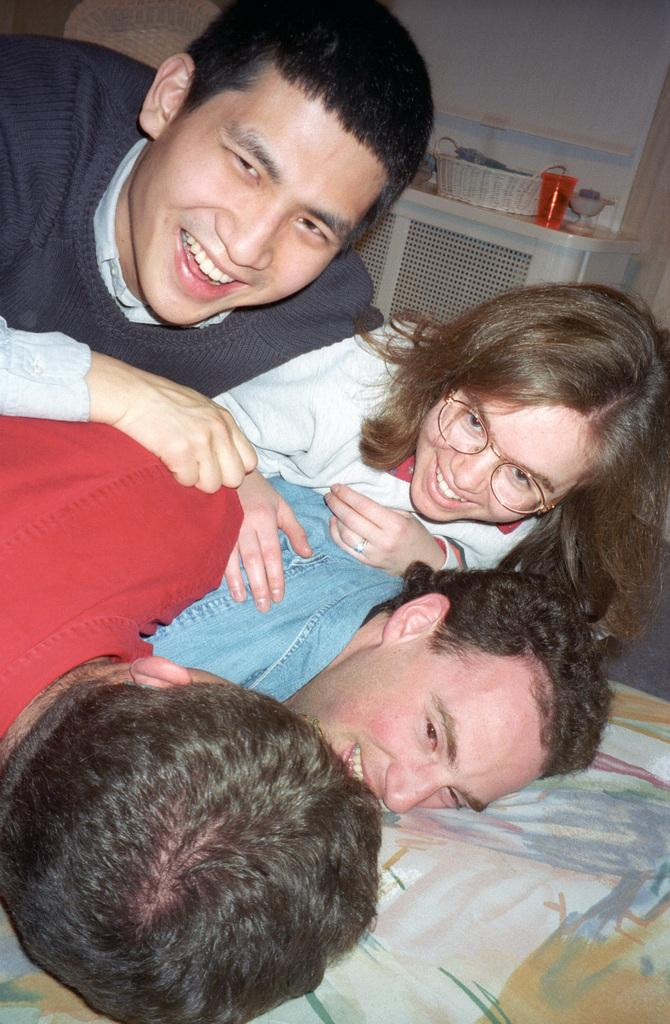How many people are in the image? There are four persons in the image. What is the facial expression of the people in the image? The persons are smiling. What object can be seen in the image besides the people? There is a basket and a glass on a platform in the image. What is visible in the background of the image? There is a wall in the background of the image. What type of string can be seen tied to the glass in the image? There is no string tied to the glass in the image. Can you see any goldfish swimming in the basket in the image? There are no goldfish present in the image; it only features a basket and a glass on a platform. 